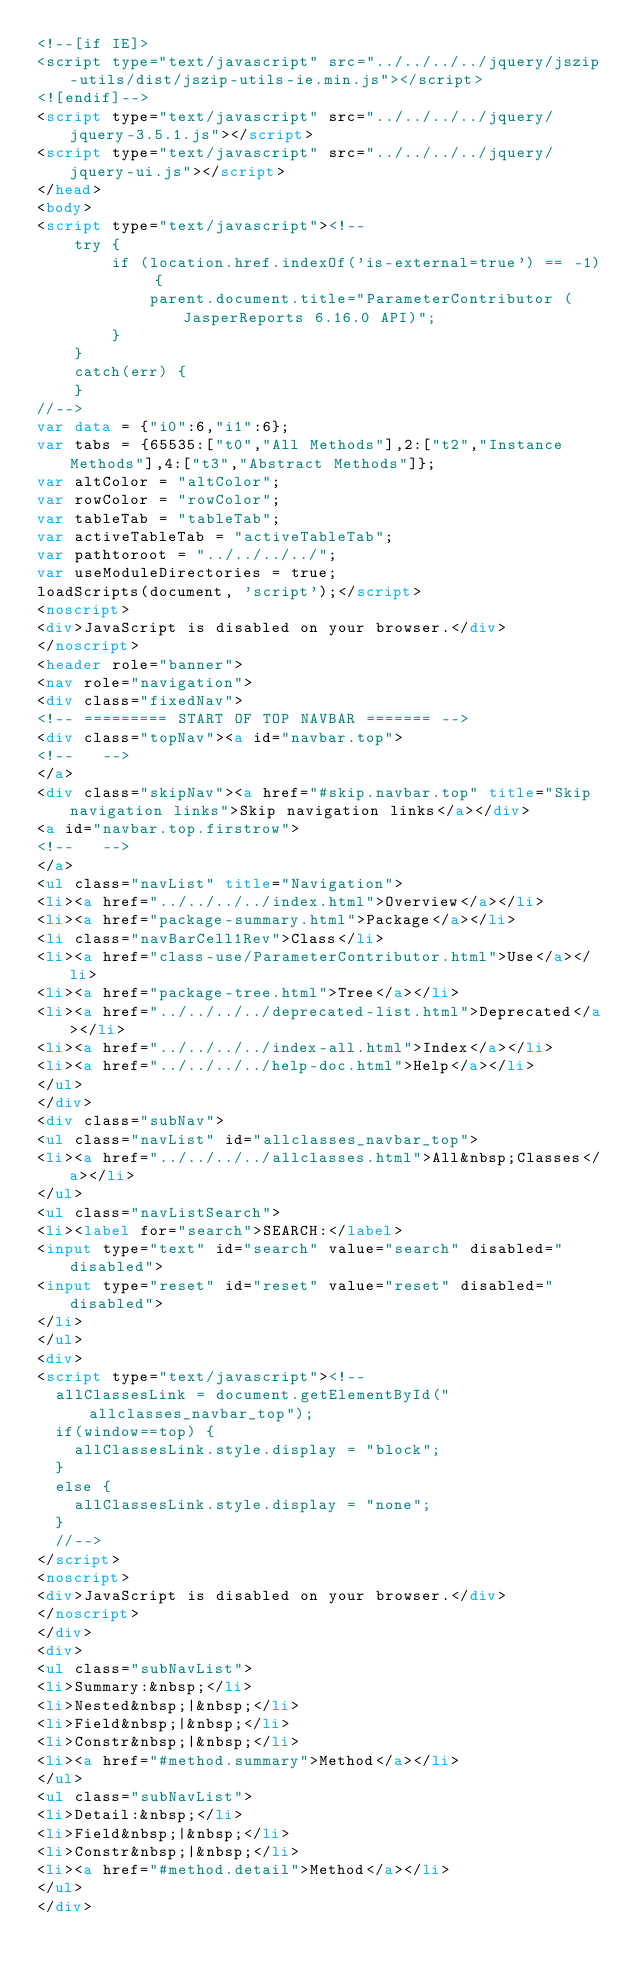<code> <loc_0><loc_0><loc_500><loc_500><_HTML_><!--[if IE]>
<script type="text/javascript" src="../../../../jquery/jszip-utils/dist/jszip-utils-ie.min.js"></script>
<![endif]-->
<script type="text/javascript" src="../../../../jquery/jquery-3.5.1.js"></script>
<script type="text/javascript" src="../../../../jquery/jquery-ui.js"></script>
</head>
<body>
<script type="text/javascript"><!--
    try {
        if (location.href.indexOf('is-external=true') == -1) {
            parent.document.title="ParameterContributor (JasperReports 6.16.0 API)";
        }
    }
    catch(err) {
    }
//-->
var data = {"i0":6,"i1":6};
var tabs = {65535:["t0","All Methods"],2:["t2","Instance Methods"],4:["t3","Abstract Methods"]};
var altColor = "altColor";
var rowColor = "rowColor";
var tableTab = "tableTab";
var activeTableTab = "activeTableTab";
var pathtoroot = "../../../../";
var useModuleDirectories = true;
loadScripts(document, 'script');</script>
<noscript>
<div>JavaScript is disabled on your browser.</div>
</noscript>
<header role="banner">
<nav role="navigation">
<div class="fixedNav">
<!-- ========= START OF TOP NAVBAR ======= -->
<div class="topNav"><a id="navbar.top">
<!--   -->
</a>
<div class="skipNav"><a href="#skip.navbar.top" title="Skip navigation links">Skip navigation links</a></div>
<a id="navbar.top.firstrow">
<!--   -->
</a>
<ul class="navList" title="Navigation">
<li><a href="../../../../index.html">Overview</a></li>
<li><a href="package-summary.html">Package</a></li>
<li class="navBarCell1Rev">Class</li>
<li><a href="class-use/ParameterContributor.html">Use</a></li>
<li><a href="package-tree.html">Tree</a></li>
<li><a href="../../../../deprecated-list.html">Deprecated</a></li>
<li><a href="../../../../index-all.html">Index</a></li>
<li><a href="../../../../help-doc.html">Help</a></li>
</ul>
</div>
<div class="subNav">
<ul class="navList" id="allclasses_navbar_top">
<li><a href="../../../../allclasses.html">All&nbsp;Classes</a></li>
</ul>
<ul class="navListSearch">
<li><label for="search">SEARCH:</label>
<input type="text" id="search" value="search" disabled="disabled">
<input type="reset" id="reset" value="reset" disabled="disabled">
</li>
</ul>
<div>
<script type="text/javascript"><!--
  allClassesLink = document.getElementById("allclasses_navbar_top");
  if(window==top) {
    allClassesLink.style.display = "block";
  }
  else {
    allClassesLink.style.display = "none";
  }
  //-->
</script>
<noscript>
<div>JavaScript is disabled on your browser.</div>
</noscript>
</div>
<div>
<ul class="subNavList">
<li>Summary:&nbsp;</li>
<li>Nested&nbsp;|&nbsp;</li>
<li>Field&nbsp;|&nbsp;</li>
<li>Constr&nbsp;|&nbsp;</li>
<li><a href="#method.summary">Method</a></li>
</ul>
<ul class="subNavList">
<li>Detail:&nbsp;</li>
<li>Field&nbsp;|&nbsp;</li>
<li>Constr&nbsp;|&nbsp;</li>
<li><a href="#method.detail">Method</a></li>
</ul>
</div></code> 